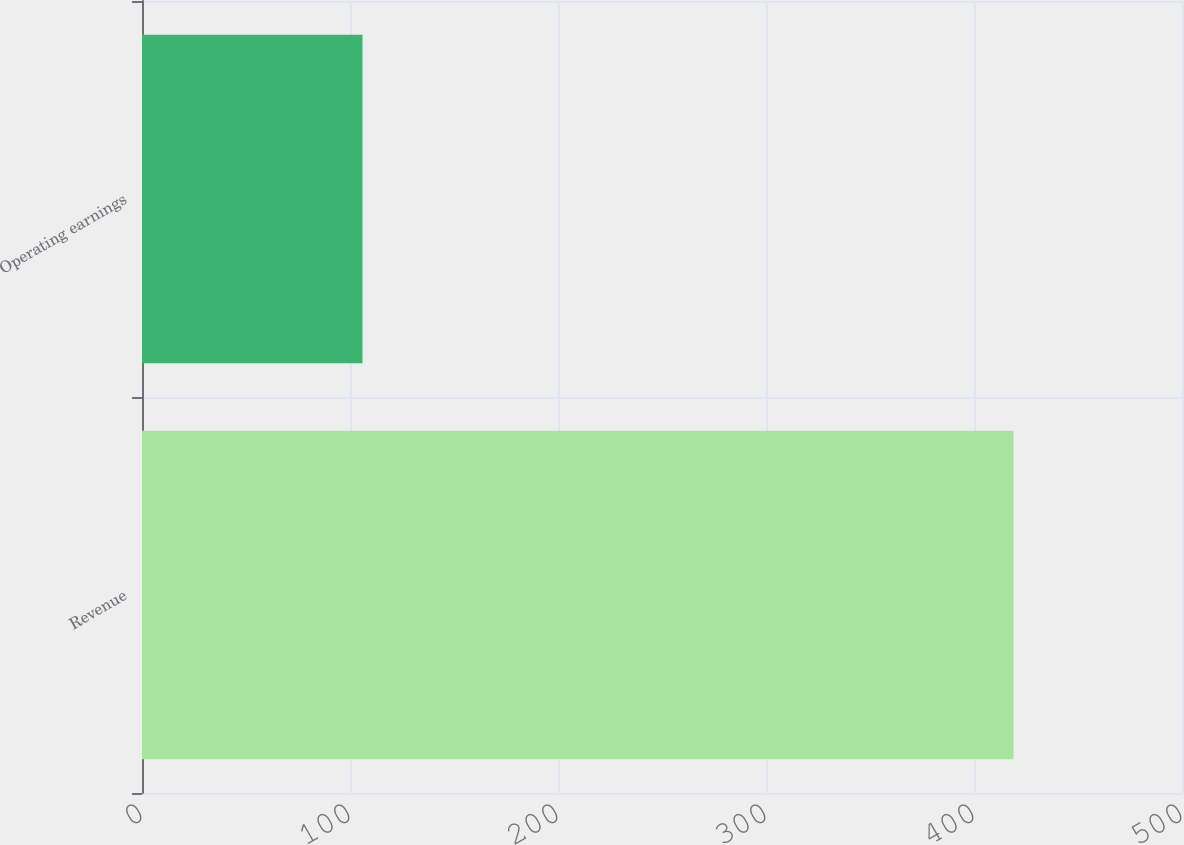Convert chart to OTSL. <chart><loc_0><loc_0><loc_500><loc_500><bar_chart><fcel>Revenue<fcel>Operating earnings<nl><fcel>419<fcel>106<nl></chart> 